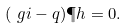Convert formula to latex. <formula><loc_0><loc_0><loc_500><loc_500>( \ g i - q ) \P h & = 0 .</formula> 